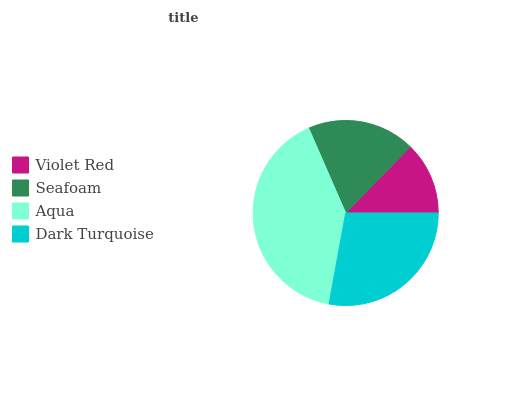Is Violet Red the minimum?
Answer yes or no. Yes. Is Aqua the maximum?
Answer yes or no. Yes. Is Seafoam the minimum?
Answer yes or no. No. Is Seafoam the maximum?
Answer yes or no. No. Is Seafoam greater than Violet Red?
Answer yes or no. Yes. Is Violet Red less than Seafoam?
Answer yes or no. Yes. Is Violet Red greater than Seafoam?
Answer yes or no. No. Is Seafoam less than Violet Red?
Answer yes or no. No. Is Dark Turquoise the high median?
Answer yes or no. Yes. Is Seafoam the low median?
Answer yes or no. Yes. Is Aqua the high median?
Answer yes or no. No. Is Violet Red the low median?
Answer yes or no. No. 